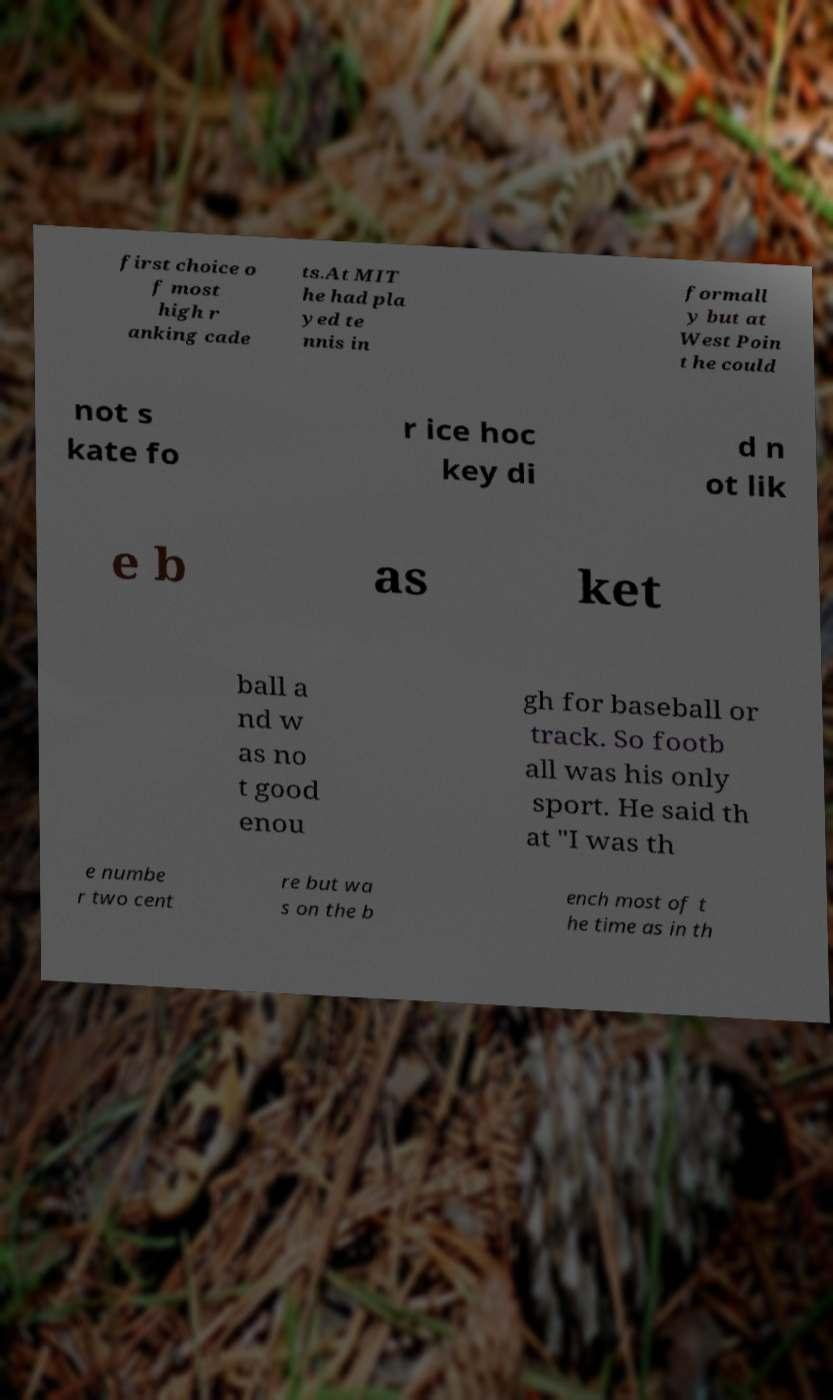What messages or text are displayed in this image? I need them in a readable, typed format. first choice o f most high r anking cade ts.At MIT he had pla yed te nnis in formall y but at West Poin t he could not s kate fo r ice hoc key di d n ot lik e b as ket ball a nd w as no t good enou gh for baseball or track. So footb all was his only sport. He said th at "I was th e numbe r two cent re but wa s on the b ench most of t he time as in th 